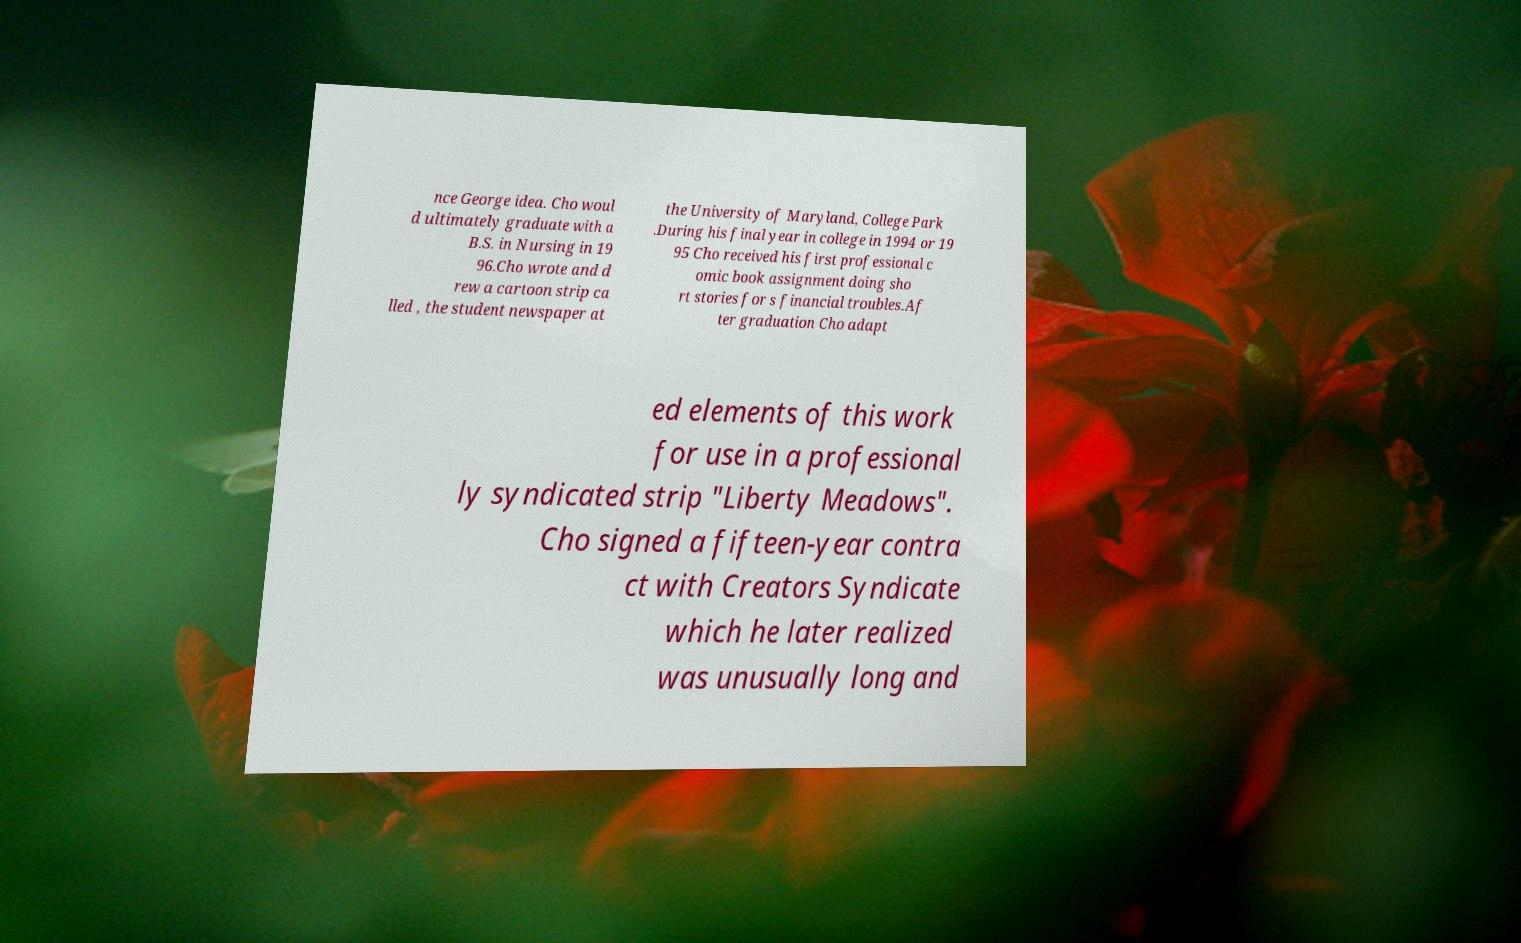For documentation purposes, I need the text within this image transcribed. Could you provide that? nce George idea. Cho woul d ultimately graduate with a B.S. in Nursing in 19 96.Cho wrote and d rew a cartoon strip ca lled , the student newspaper at the University of Maryland, College Park .During his final year in college in 1994 or 19 95 Cho received his first professional c omic book assignment doing sho rt stories for s financial troubles.Af ter graduation Cho adapt ed elements of this work for use in a professional ly syndicated strip "Liberty Meadows". Cho signed a fifteen-year contra ct with Creators Syndicate which he later realized was unusually long and 